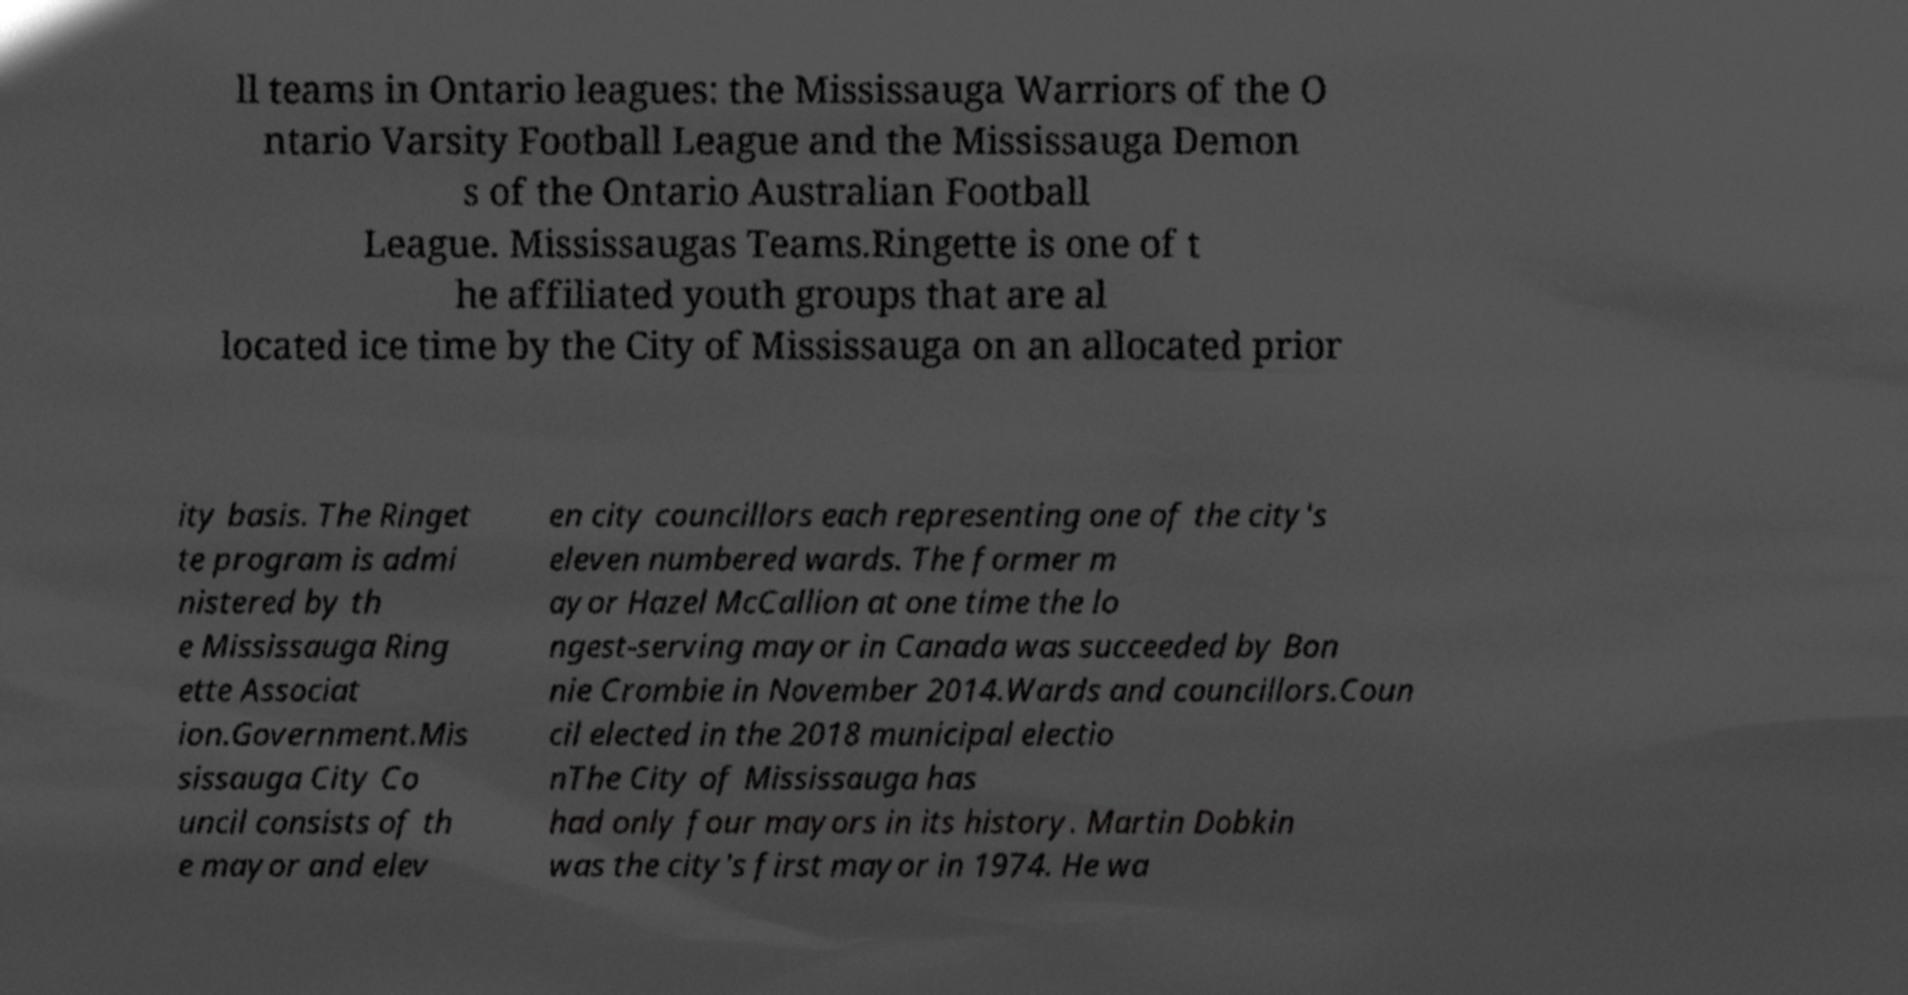Please read and relay the text visible in this image. What does it say? ll teams in Ontario leagues: the Mississauga Warriors of the O ntario Varsity Football League and the Mississauga Demon s of the Ontario Australian Football League. Mississaugas Teams.Ringette is one of t he affiliated youth groups that are al located ice time by the City of Mississauga on an allocated prior ity basis. The Ringet te program is admi nistered by th e Mississauga Ring ette Associat ion.Government.Mis sissauga City Co uncil consists of th e mayor and elev en city councillors each representing one of the city's eleven numbered wards. The former m ayor Hazel McCallion at one time the lo ngest-serving mayor in Canada was succeeded by Bon nie Crombie in November 2014.Wards and councillors.Coun cil elected in the 2018 municipal electio nThe City of Mississauga has had only four mayors in its history. Martin Dobkin was the city's first mayor in 1974. He wa 